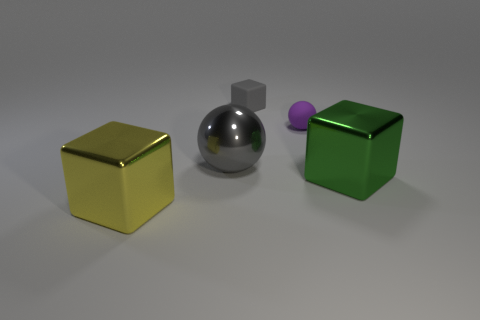Add 3 big purple metal cylinders. How many objects exist? 8 Subtract all balls. How many objects are left? 3 Subtract all yellow things. Subtract all green cubes. How many objects are left? 3 Add 4 green objects. How many green objects are left? 5 Add 5 metallic spheres. How many metallic spheres exist? 6 Subtract 1 purple spheres. How many objects are left? 4 